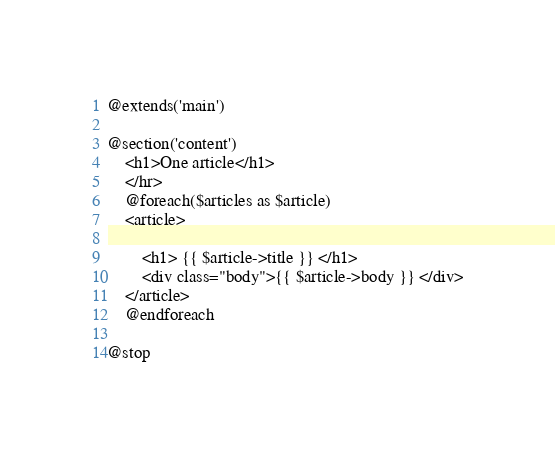<code> <loc_0><loc_0><loc_500><loc_500><_PHP_>@extends('main')

@section('content')
	<h1>One article</h1>
	</hr>
	@foreach($articles as $article)
	<article>
		
		<h1> {{ $article->title }} </h1>
		<div class="body">{{ $article->body }} </div>
	</article>
	@endforeach

@stop</code> 